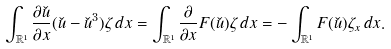<formula> <loc_0><loc_0><loc_500><loc_500>\int _ { \mathbb { R } ^ { 1 } } \frac { \partial \check { u } } { \partial x } ( \check { u } - \check { u } ^ { 3 } ) \zeta \, d x = \int _ { \mathbb { R } ^ { 1 } } \frac { \partial } { \partial x } F ( \check { u } ) \zeta \, d x = - \int _ { \mathbb { R } ^ { 1 } } F ( \check { u } ) \zeta _ { x } \, d x .</formula> 